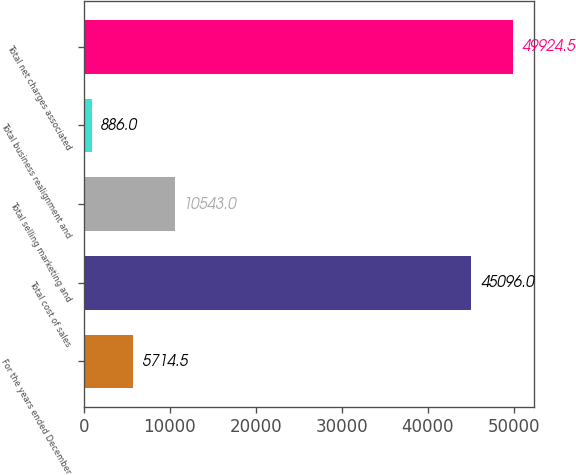Convert chart to OTSL. <chart><loc_0><loc_0><loc_500><loc_500><bar_chart><fcel>For the years ended December<fcel>Total cost of sales<fcel>Total selling marketing and<fcel>Total business realignment and<fcel>Total net charges associated<nl><fcel>5714.5<fcel>45096<fcel>10543<fcel>886<fcel>49924.5<nl></chart> 